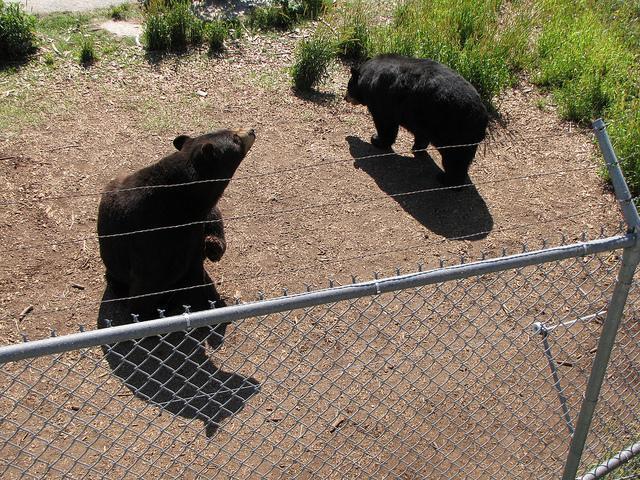How many bears are there?
Give a very brief answer. 2. How many bears are visible?
Give a very brief answer. 2. 